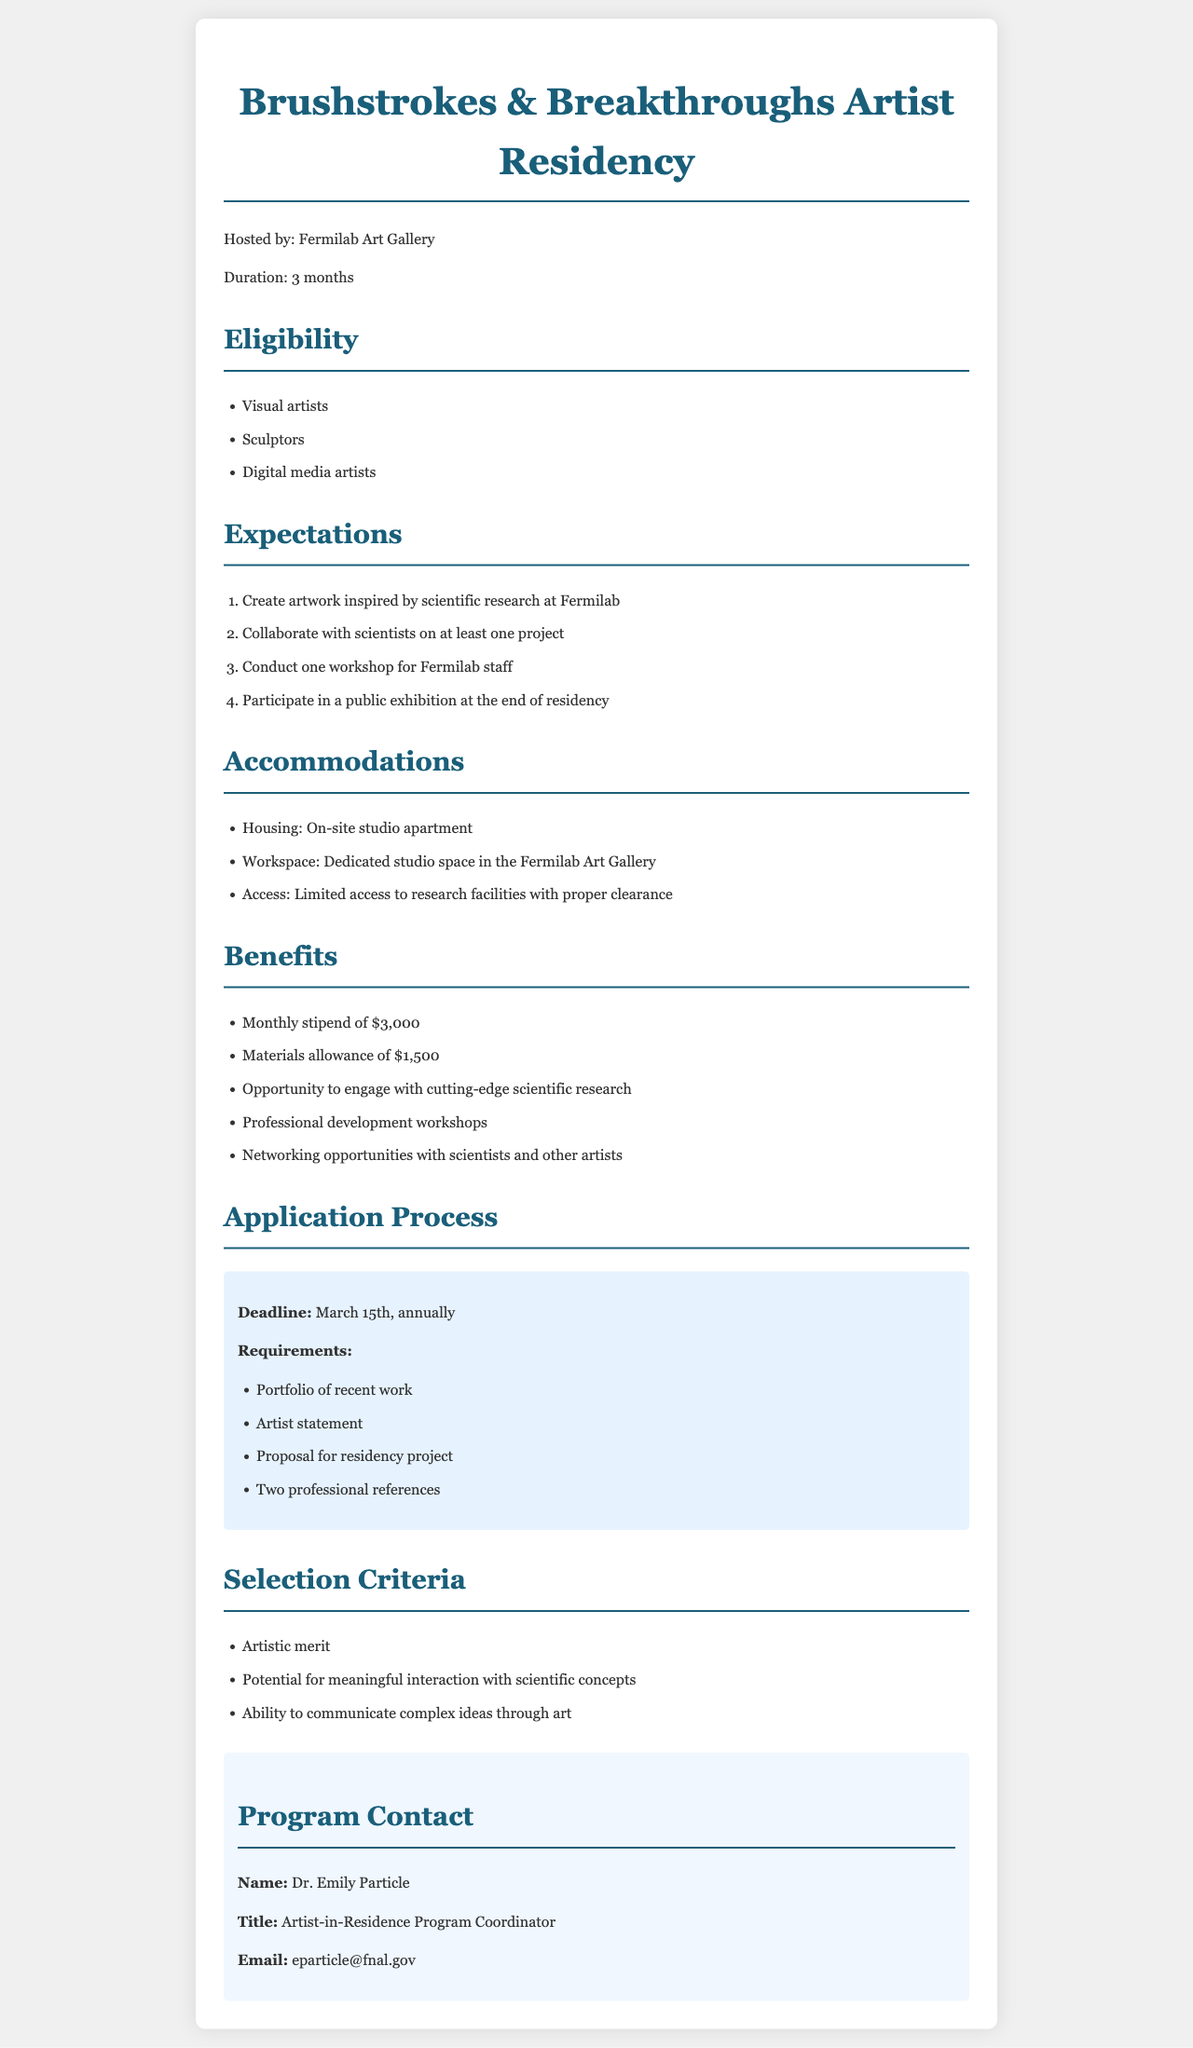What is the duration of the residency? The duration of the residency is explicitly stated in the document as three months.
Answer: 3 months Who is the host of the artist residency? The document specifies that the artist residency is hosted by the Fermilab Art Gallery.
Answer: Fermilab Art Gallery What is the monthly stipend for participating artists? The document provides a specific amount for the monthly stipend that participating artists will receive.
Answer: $3,000 What are participating artists expected to do at the residency? The expectations listed require artists to create artwork inspired by scientific research and collaborate with scientists as part of the program.
Answer: Create artwork inspired by scientific research What is one of the requirements for the application? The document lists specific application requirements, including items that must be submitted by applicants.
Answer: Portfolio of recent work How many professional references are required for the application? The document indicates a specific number of professional references that applicants must include with their application.
Answer: Two professional references What type of artists are eligible for the program? The document outlines the types of artists that are eligible for participation in the residency.
Answer: Visual artists, sculptors, digital media artists What is the deadline for application submission? The document clearly states the deadline by which applications must be submitted for the residency program.
Answer: March 15th Who should be contacted for more information about the program? The document provides the name and contact information for the person responsible for the residency program.
Answer: Dr. Emily Particle 